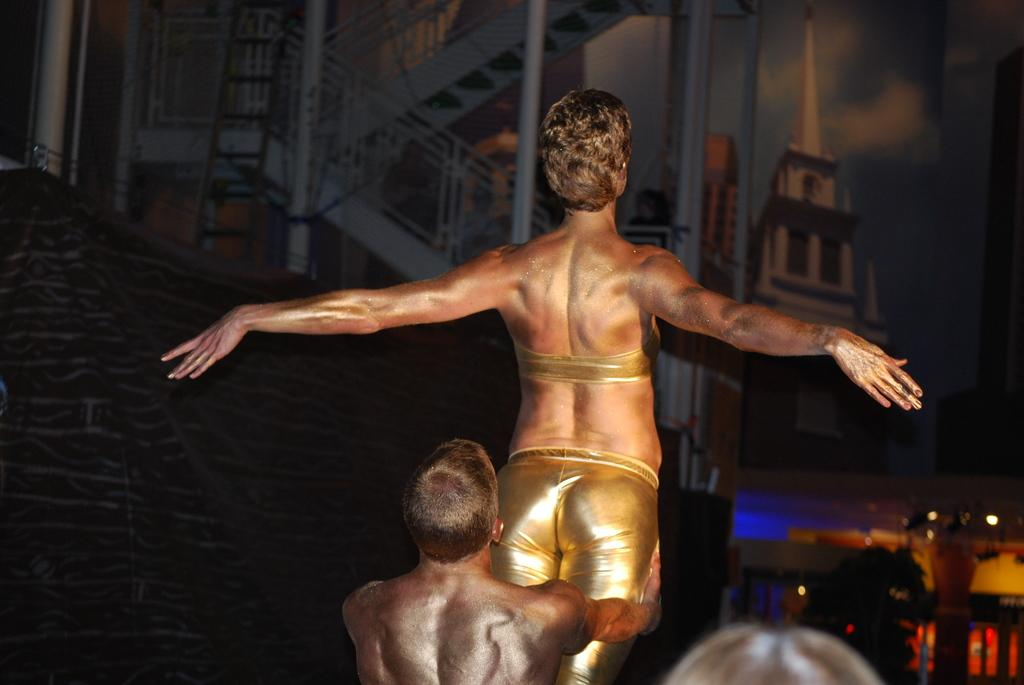What is the main subject of the image? There is a man in the image. What is the man doing in the image? The man is lifting a person in the image. What can be seen in the background of the image? There is a ladder, a building, and lights in the background of the image. What type of teeth can be seen in the image? There are no teeth visible in the image. What kind of debt is the man in the image trying to pay off? There is no indication of debt in the image; it shows a man lifting a person. 